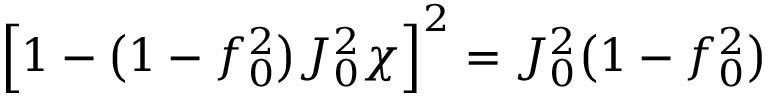<formula> <loc_0><loc_0><loc_500><loc_500>\left [ 1 - \left ( 1 - f _ { 0 } ^ { 2 } \right ) J _ { 0 } ^ { 2 } \chi \right ] ^ { 2 } = J _ { 0 } ^ { 2 } \left ( 1 - f _ { 0 } ^ { 2 } \right )</formula> 